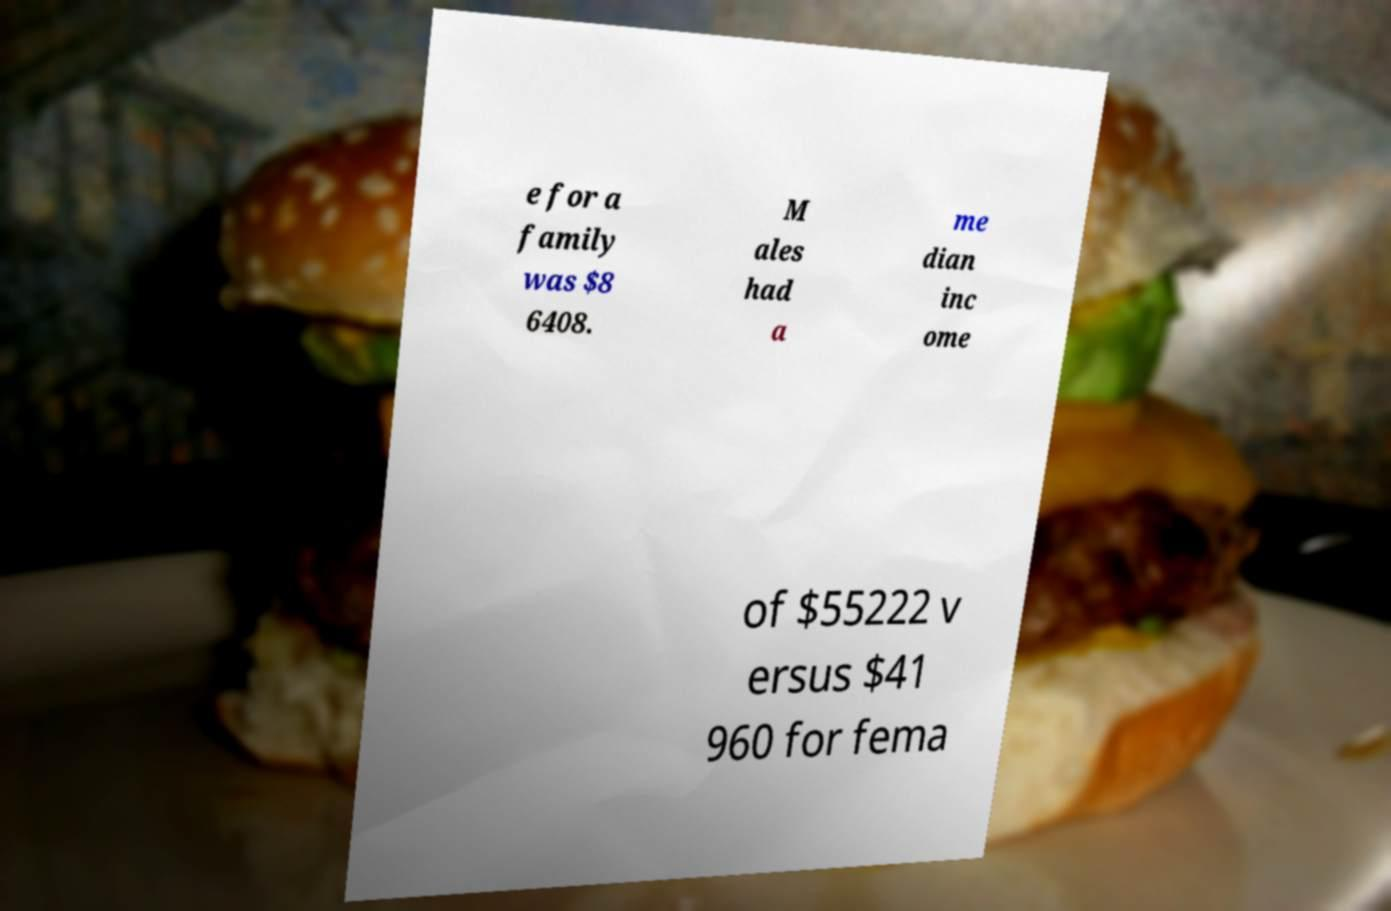I need the written content from this picture converted into text. Can you do that? e for a family was $8 6408. M ales had a me dian inc ome of $55222 v ersus $41 960 for fema 